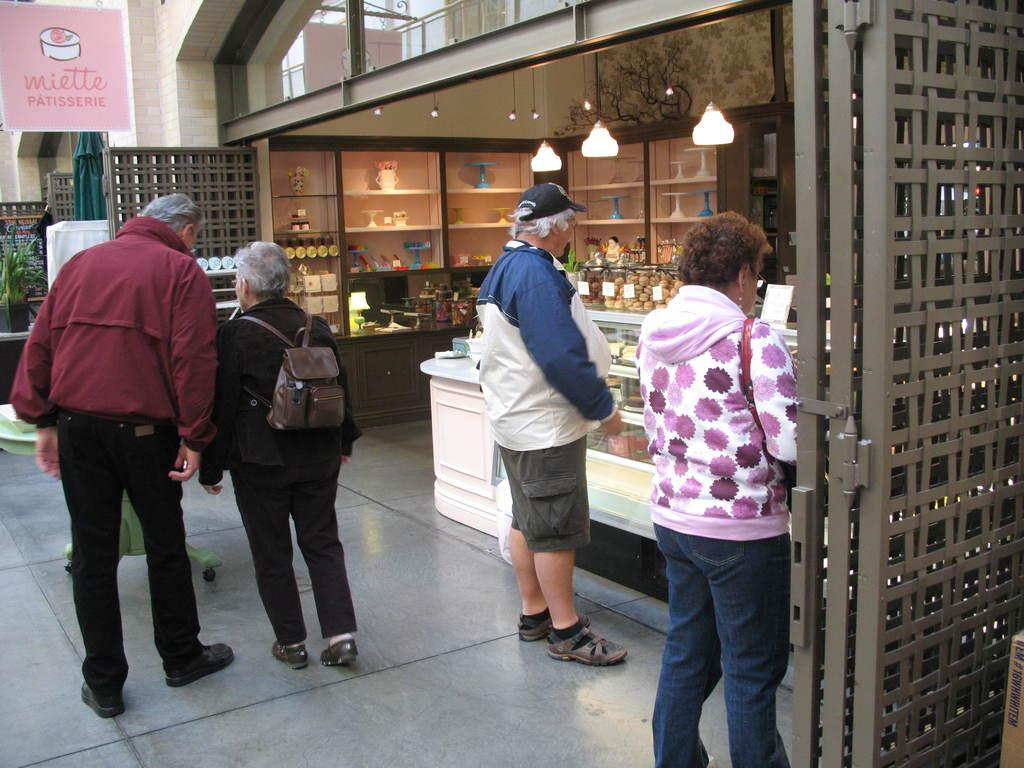What are the two people in the foreground of the image doing? There is a man and a woman walking in the path. Can you describe the people in the background of the image? There is a woman and a man waiting near a shop in the background. How many snails can be seen crawling on the toy in the scene? There are no snails or toys present in the image; it features two people walking and two people waiting near a shop. 